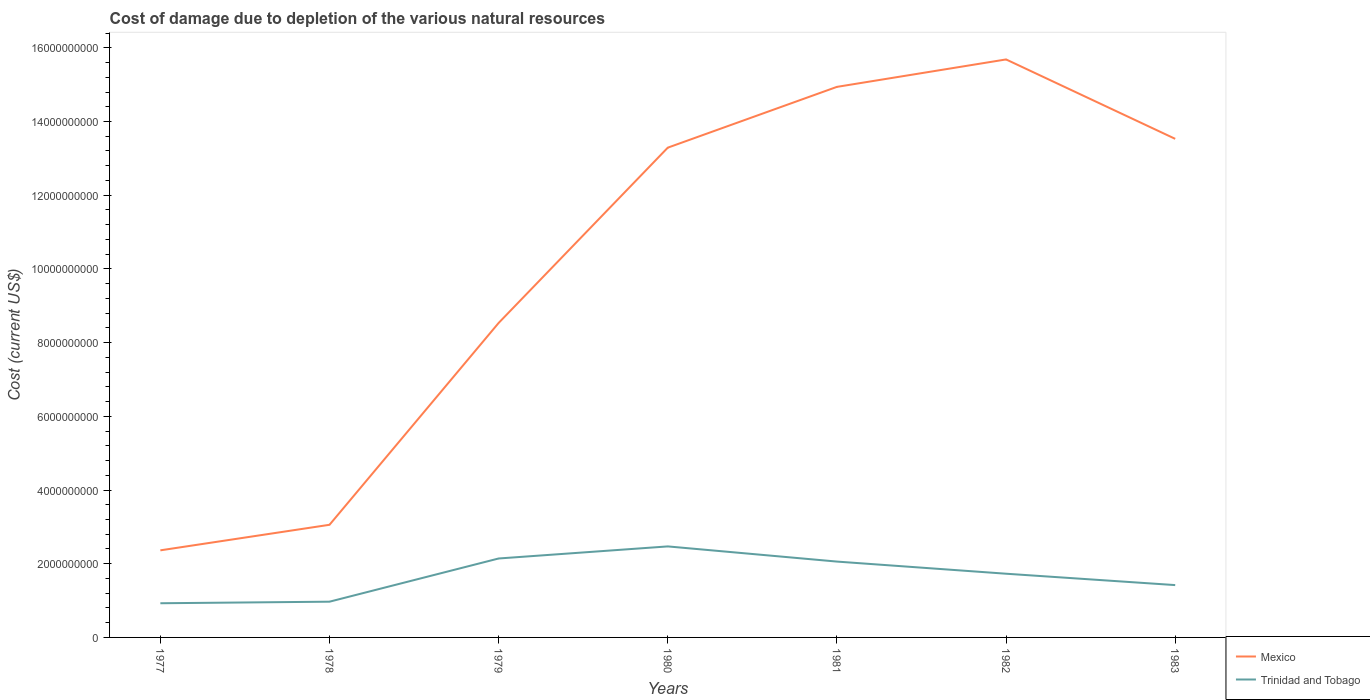Does the line corresponding to Mexico intersect with the line corresponding to Trinidad and Tobago?
Provide a short and direct response. No. Is the number of lines equal to the number of legend labels?
Provide a succinct answer. Yes. Across all years, what is the maximum cost of damage caused due to the depletion of various natural resources in Trinidad and Tobago?
Your answer should be compact. 9.27e+08. In which year was the cost of damage caused due to the depletion of various natural resources in Trinidad and Tobago maximum?
Offer a very short reply. 1977. What is the total cost of damage caused due to the depletion of various natural resources in Mexico in the graph?
Offer a very short reply. -2.39e+09. What is the difference between the highest and the second highest cost of damage caused due to the depletion of various natural resources in Mexico?
Provide a short and direct response. 1.33e+1. How many lines are there?
Your answer should be compact. 2. Does the graph contain grids?
Provide a succinct answer. No. How many legend labels are there?
Give a very brief answer. 2. What is the title of the graph?
Your response must be concise. Cost of damage due to depletion of the various natural resources. What is the label or title of the Y-axis?
Your answer should be compact. Cost (current US$). What is the Cost (current US$) of Mexico in 1977?
Offer a very short reply. 2.36e+09. What is the Cost (current US$) of Trinidad and Tobago in 1977?
Offer a very short reply. 9.27e+08. What is the Cost (current US$) of Mexico in 1978?
Keep it short and to the point. 3.06e+09. What is the Cost (current US$) in Trinidad and Tobago in 1978?
Your answer should be very brief. 9.70e+08. What is the Cost (current US$) of Mexico in 1979?
Provide a succinct answer. 8.53e+09. What is the Cost (current US$) in Trinidad and Tobago in 1979?
Your answer should be very brief. 2.14e+09. What is the Cost (current US$) in Mexico in 1980?
Provide a succinct answer. 1.33e+1. What is the Cost (current US$) in Trinidad and Tobago in 1980?
Provide a short and direct response. 2.47e+09. What is the Cost (current US$) in Mexico in 1981?
Offer a very short reply. 1.49e+1. What is the Cost (current US$) of Trinidad and Tobago in 1981?
Offer a terse response. 2.06e+09. What is the Cost (current US$) of Mexico in 1982?
Ensure brevity in your answer.  1.57e+1. What is the Cost (current US$) in Trinidad and Tobago in 1982?
Provide a short and direct response. 1.73e+09. What is the Cost (current US$) in Mexico in 1983?
Ensure brevity in your answer.  1.35e+1. What is the Cost (current US$) of Trinidad and Tobago in 1983?
Make the answer very short. 1.42e+09. Across all years, what is the maximum Cost (current US$) in Mexico?
Your answer should be compact. 1.57e+1. Across all years, what is the maximum Cost (current US$) of Trinidad and Tobago?
Ensure brevity in your answer.  2.47e+09. Across all years, what is the minimum Cost (current US$) in Mexico?
Your answer should be compact. 2.36e+09. Across all years, what is the minimum Cost (current US$) in Trinidad and Tobago?
Provide a succinct answer. 9.27e+08. What is the total Cost (current US$) in Mexico in the graph?
Provide a succinct answer. 7.14e+1. What is the total Cost (current US$) in Trinidad and Tobago in the graph?
Keep it short and to the point. 1.17e+1. What is the difference between the Cost (current US$) of Mexico in 1977 and that in 1978?
Provide a succinct answer. -6.93e+08. What is the difference between the Cost (current US$) of Trinidad and Tobago in 1977 and that in 1978?
Your answer should be compact. -4.25e+07. What is the difference between the Cost (current US$) of Mexico in 1977 and that in 1979?
Your response must be concise. -6.17e+09. What is the difference between the Cost (current US$) in Trinidad and Tobago in 1977 and that in 1979?
Keep it short and to the point. -1.21e+09. What is the difference between the Cost (current US$) of Mexico in 1977 and that in 1980?
Offer a terse response. -1.09e+1. What is the difference between the Cost (current US$) of Trinidad and Tobago in 1977 and that in 1980?
Ensure brevity in your answer.  -1.54e+09. What is the difference between the Cost (current US$) of Mexico in 1977 and that in 1981?
Offer a terse response. -1.26e+1. What is the difference between the Cost (current US$) in Trinidad and Tobago in 1977 and that in 1981?
Your response must be concise. -1.13e+09. What is the difference between the Cost (current US$) of Mexico in 1977 and that in 1982?
Offer a terse response. -1.33e+1. What is the difference between the Cost (current US$) in Trinidad and Tobago in 1977 and that in 1982?
Provide a short and direct response. -8.02e+08. What is the difference between the Cost (current US$) of Mexico in 1977 and that in 1983?
Your answer should be compact. -1.12e+1. What is the difference between the Cost (current US$) in Trinidad and Tobago in 1977 and that in 1983?
Ensure brevity in your answer.  -4.93e+08. What is the difference between the Cost (current US$) in Mexico in 1978 and that in 1979?
Ensure brevity in your answer.  -5.48e+09. What is the difference between the Cost (current US$) of Trinidad and Tobago in 1978 and that in 1979?
Your answer should be compact. -1.17e+09. What is the difference between the Cost (current US$) of Mexico in 1978 and that in 1980?
Make the answer very short. -1.02e+1. What is the difference between the Cost (current US$) in Trinidad and Tobago in 1978 and that in 1980?
Give a very brief answer. -1.50e+09. What is the difference between the Cost (current US$) of Mexico in 1978 and that in 1981?
Provide a short and direct response. -1.19e+1. What is the difference between the Cost (current US$) in Trinidad and Tobago in 1978 and that in 1981?
Make the answer very short. -1.09e+09. What is the difference between the Cost (current US$) of Mexico in 1978 and that in 1982?
Offer a very short reply. -1.26e+1. What is the difference between the Cost (current US$) in Trinidad and Tobago in 1978 and that in 1982?
Give a very brief answer. -7.59e+08. What is the difference between the Cost (current US$) of Mexico in 1978 and that in 1983?
Ensure brevity in your answer.  -1.05e+1. What is the difference between the Cost (current US$) in Trinidad and Tobago in 1978 and that in 1983?
Provide a short and direct response. -4.50e+08. What is the difference between the Cost (current US$) in Mexico in 1979 and that in 1980?
Offer a very short reply. -4.76e+09. What is the difference between the Cost (current US$) of Trinidad and Tobago in 1979 and that in 1980?
Provide a short and direct response. -3.28e+08. What is the difference between the Cost (current US$) of Mexico in 1979 and that in 1981?
Provide a succinct answer. -6.41e+09. What is the difference between the Cost (current US$) of Trinidad and Tobago in 1979 and that in 1981?
Provide a succinct answer. 8.39e+07. What is the difference between the Cost (current US$) in Mexico in 1979 and that in 1982?
Provide a succinct answer. -7.15e+09. What is the difference between the Cost (current US$) of Trinidad and Tobago in 1979 and that in 1982?
Keep it short and to the point. 4.13e+08. What is the difference between the Cost (current US$) of Mexico in 1979 and that in 1983?
Offer a terse response. -5.00e+09. What is the difference between the Cost (current US$) of Trinidad and Tobago in 1979 and that in 1983?
Offer a terse response. 7.22e+08. What is the difference between the Cost (current US$) of Mexico in 1980 and that in 1981?
Give a very brief answer. -1.65e+09. What is the difference between the Cost (current US$) in Trinidad and Tobago in 1980 and that in 1981?
Ensure brevity in your answer.  4.12e+08. What is the difference between the Cost (current US$) in Mexico in 1980 and that in 1982?
Provide a succinct answer. -2.39e+09. What is the difference between the Cost (current US$) in Trinidad and Tobago in 1980 and that in 1982?
Give a very brief answer. 7.41e+08. What is the difference between the Cost (current US$) in Mexico in 1980 and that in 1983?
Offer a terse response. -2.39e+08. What is the difference between the Cost (current US$) in Trinidad and Tobago in 1980 and that in 1983?
Your response must be concise. 1.05e+09. What is the difference between the Cost (current US$) of Mexico in 1981 and that in 1982?
Your answer should be very brief. -7.44e+08. What is the difference between the Cost (current US$) in Trinidad and Tobago in 1981 and that in 1982?
Your answer should be very brief. 3.29e+08. What is the difference between the Cost (current US$) in Mexico in 1981 and that in 1983?
Offer a terse response. 1.41e+09. What is the difference between the Cost (current US$) in Trinidad and Tobago in 1981 and that in 1983?
Give a very brief answer. 6.38e+08. What is the difference between the Cost (current US$) in Mexico in 1982 and that in 1983?
Give a very brief answer. 2.15e+09. What is the difference between the Cost (current US$) of Trinidad and Tobago in 1982 and that in 1983?
Your response must be concise. 3.09e+08. What is the difference between the Cost (current US$) of Mexico in 1977 and the Cost (current US$) of Trinidad and Tobago in 1978?
Make the answer very short. 1.39e+09. What is the difference between the Cost (current US$) in Mexico in 1977 and the Cost (current US$) in Trinidad and Tobago in 1979?
Offer a very short reply. 2.21e+08. What is the difference between the Cost (current US$) of Mexico in 1977 and the Cost (current US$) of Trinidad and Tobago in 1980?
Provide a short and direct response. -1.07e+08. What is the difference between the Cost (current US$) of Mexico in 1977 and the Cost (current US$) of Trinidad and Tobago in 1981?
Keep it short and to the point. 3.05e+08. What is the difference between the Cost (current US$) in Mexico in 1977 and the Cost (current US$) in Trinidad and Tobago in 1982?
Ensure brevity in your answer.  6.34e+08. What is the difference between the Cost (current US$) in Mexico in 1977 and the Cost (current US$) in Trinidad and Tobago in 1983?
Give a very brief answer. 9.43e+08. What is the difference between the Cost (current US$) of Mexico in 1978 and the Cost (current US$) of Trinidad and Tobago in 1979?
Your answer should be compact. 9.14e+08. What is the difference between the Cost (current US$) of Mexico in 1978 and the Cost (current US$) of Trinidad and Tobago in 1980?
Provide a short and direct response. 5.86e+08. What is the difference between the Cost (current US$) of Mexico in 1978 and the Cost (current US$) of Trinidad and Tobago in 1981?
Offer a terse response. 9.98e+08. What is the difference between the Cost (current US$) of Mexico in 1978 and the Cost (current US$) of Trinidad and Tobago in 1982?
Ensure brevity in your answer.  1.33e+09. What is the difference between the Cost (current US$) in Mexico in 1978 and the Cost (current US$) in Trinidad and Tobago in 1983?
Keep it short and to the point. 1.64e+09. What is the difference between the Cost (current US$) in Mexico in 1979 and the Cost (current US$) in Trinidad and Tobago in 1980?
Ensure brevity in your answer.  6.06e+09. What is the difference between the Cost (current US$) of Mexico in 1979 and the Cost (current US$) of Trinidad and Tobago in 1981?
Keep it short and to the point. 6.48e+09. What is the difference between the Cost (current US$) in Mexico in 1979 and the Cost (current US$) in Trinidad and Tobago in 1982?
Offer a very short reply. 6.81e+09. What is the difference between the Cost (current US$) in Mexico in 1979 and the Cost (current US$) in Trinidad and Tobago in 1983?
Make the answer very short. 7.11e+09. What is the difference between the Cost (current US$) in Mexico in 1980 and the Cost (current US$) in Trinidad and Tobago in 1981?
Your answer should be very brief. 1.12e+1. What is the difference between the Cost (current US$) of Mexico in 1980 and the Cost (current US$) of Trinidad and Tobago in 1982?
Provide a succinct answer. 1.16e+1. What is the difference between the Cost (current US$) of Mexico in 1980 and the Cost (current US$) of Trinidad and Tobago in 1983?
Give a very brief answer. 1.19e+1. What is the difference between the Cost (current US$) of Mexico in 1981 and the Cost (current US$) of Trinidad and Tobago in 1982?
Your answer should be compact. 1.32e+1. What is the difference between the Cost (current US$) of Mexico in 1981 and the Cost (current US$) of Trinidad and Tobago in 1983?
Keep it short and to the point. 1.35e+1. What is the difference between the Cost (current US$) of Mexico in 1982 and the Cost (current US$) of Trinidad and Tobago in 1983?
Offer a terse response. 1.43e+1. What is the average Cost (current US$) of Mexico per year?
Give a very brief answer. 1.02e+1. What is the average Cost (current US$) of Trinidad and Tobago per year?
Provide a succinct answer. 1.67e+09. In the year 1977, what is the difference between the Cost (current US$) of Mexico and Cost (current US$) of Trinidad and Tobago?
Your response must be concise. 1.44e+09. In the year 1978, what is the difference between the Cost (current US$) in Mexico and Cost (current US$) in Trinidad and Tobago?
Keep it short and to the point. 2.09e+09. In the year 1979, what is the difference between the Cost (current US$) of Mexico and Cost (current US$) of Trinidad and Tobago?
Provide a succinct answer. 6.39e+09. In the year 1980, what is the difference between the Cost (current US$) of Mexico and Cost (current US$) of Trinidad and Tobago?
Ensure brevity in your answer.  1.08e+1. In the year 1981, what is the difference between the Cost (current US$) of Mexico and Cost (current US$) of Trinidad and Tobago?
Make the answer very short. 1.29e+1. In the year 1982, what is the difference between the Cost (current US$) in Mexico and Cost (current US$) in Trinidad and Tobago?
Offer a very short reply. 1.40e+1. In the year 1983, what is the difference between the Cost (current US$) in Mexico and Cost (current US$) in Trinidad and Tobago?
Offer a very short reply. 1.21e+1. What is the ratio of the Cost (current US$) of Mexico in 1977 to that in 1978?
Give a very brief answer. 0.77. What is the ratio of the Cost (current US$) in Trinidad and Tobago in 1977 to that in 1978?
Make the answer very short. 0.96. What is the ratio of the Cost (current US$) in Mexico in 1977 to that in 1979?
Your response must be concise. 0.28. What is the ratio of the Cost (current US$) of Trinidad and Tobago in 1977 to that in 1979?
Your response must be concise. 0.43. What is the ratio of the Cost (current US$) of Mexico in 1977 to that in 1980?
Your answer should be compact. 0.18. What is the ratio of the Cost (current US$) in Trinidad and Tobago in 1977 to that in 1980?
Your answer should be compact. 0.38. What is the ratio of the Cost (current US$) in Mexico in 1977 to that in 1981?
Your response must be concise. 0.16. What is the ratio of the Cost (current US$) in Trinidad and Tobago in 1977 to that in 1981?
Your response must be concise. 0.45. What is the ratio of the Cost (current US$) in Mexico in 1977 to that in 1982?
Your response must be concise. 0.15. What is the ratio of the Cost (current US$) in Trinidad and Tobago in 1977 to that in 1982?
Provide a succinct answer. 0.54. What is the ratio of the Cost (current US$) of Mexico in 1977 to that in 1983?
Ensure brevity in your answer.  0.17. What is the ratio of the Cost (current US$) of Trinidad and Tobago in 1977 to that in 1983?
Provide a short and direct response. 0.65. What is the ratio of the Cost (current US$) in Mexico in 1978 to that in 1979?
Make the answer very short. 0.36. What is the ratio of the Cost (current US$) of Trinidad and Tobago in 1978 to that in 1979?
Your response must be concise. 0.45. What is the ratio of the Cost (current US$) of Mexico in 1978 to that in 1980?
Offer a very short reply. 0.23. What is the ratio of the Cost (current US$) in Trinidad and Tobago in 1978 to that in 1980?
Your answer should be compact. 0.39. What is the ratio of the Cost (current US$) in Mexico in 1978 to that in 1981?
Your response must be concise. 0.2. What is the ratio of the Cost (current US$) in Trinidad and Tobago in 1978 to that in 1981?
Your response must be concise. 0.47. What is the ratio of the Cost (current US$) of Mexico in 1978 to that in 1982?
Your answer should be very brief. 0.19. What is the ratio of the Cost (current US$) of Trinidad and Tobago in 1978 to that in 1982?
Your response must be concise. 0.56. What is the ratio of the Cost (current US$) in Mexico in 1978 to that in 1983?
Offer a very short reply. 0.23. What is the ratio of the Cost (current US$) of Trinidad and Tobago in 1978 to that in 1983?
Your answer should be compact. 0.68. What is the ratio of the Cost (current US$) in Mexico in 1979 to that in 1980?
Provide a short and direct response. 0.64. What is the ratio of the Cost (current US$) in Trinidad and Tobago in 1979 to that in 1980?
Offer a terse response. 0.87. What is the ratio of the Cost (current US$) of Mexico in 1979 to that in 1981?
Make the answer very short. 0.57. What is the ratio of the Cost (current US$) in Trinidad and Tobago in 1979 to that in 1981?
Provide a succinct answer. 1.04. What is the ratio of the Cost (current US$) in Mexico in 1979 to that in 1982?
Keep it short and to the point. 0.54. What is the ratio of the Cost (current US$) in Trinidad and Tobago in 1979 to that in 1982?
Provide a short and direct response. 1.24. What is the ratio of the Cost (current US$) of Mexico in 1979 to that in 1983?
Provide a short and direct response. 0.63. What is the ratio of the Cost (current US$) in Trinidad and Tobago in 1979 to that in 1983?
Offer a terse response. 1.51. What is the ratio of the Cost (current US$) of Mexico in 1980 to that in 1981?
Keep it short and to the point. 0.89. What is the ratio of the Cost (current US$) of Trinidad and Tobago in 1980 to that in 1981?
Provide a succinct answer. 1.2. What is the ratio of the Cost (current US$) in Mexico in 1980 to that in 1982?
Offer a very short reply. 0.85. What is the ratio of the Cost (current US$) of Trinidad and Tobago in 1980 to that in 1982?
Provide a succinct answer. 1.43. What is the ratio of the Cost (current US$) in Mexico in 1980 to that in 1983?
Ensure brevity in your answer.  0.98. What is the ratio of the Cost (current US$) in Trinidad and Tobago in 1980 to that in 1983?
Your answer should be very brief. 1.74. What is the ratio of the Cost (current US$) in Mexico in 1981 to that in 1982?
Your response must be concise. 0.95. What is the ratio of the Cost (current US$) of Trinidad and Tobago in 1981 to that in 1982?
Your answer should be very brief. 1.19. What is the ratio of the Cost (current US$) of Mexico in 1981 to that in 1983?
Ensure brevity in your answer.  1.1. What is the ratio of the Cost (current US$) of Trinidad and Tobago in 1981 to that in 1983?
Give a very brief answer. 1.45. What is the ratio of the Cost (current US$) in Mexico in 1982 to that in 1983?
Offer a very short reply. 1.16. What is the ratio of the Cost (current US$) in Trinidad and Tobago in 1982 to that in 1983?
Ensure brevity in your answer.  1.22. What is the difference between the highest and the second highest Cost (current US$) of Mexico?
Give a very brief answer. 7.44e+08. What is the difference between the highest and the second highest Cost (current US$) of Trinidad and Tobago?
Provide a short and direct response. 3.28e+08. What is the difference between the highest and the lowest Cost (current US$) in Mexico?
Ensure brevity in your answer.  1.33e+1. What is the difference between the highest and the lowest Cost (current US$) of Trinidad and Tobago?
Offer a terse response. 1.54e+09. 